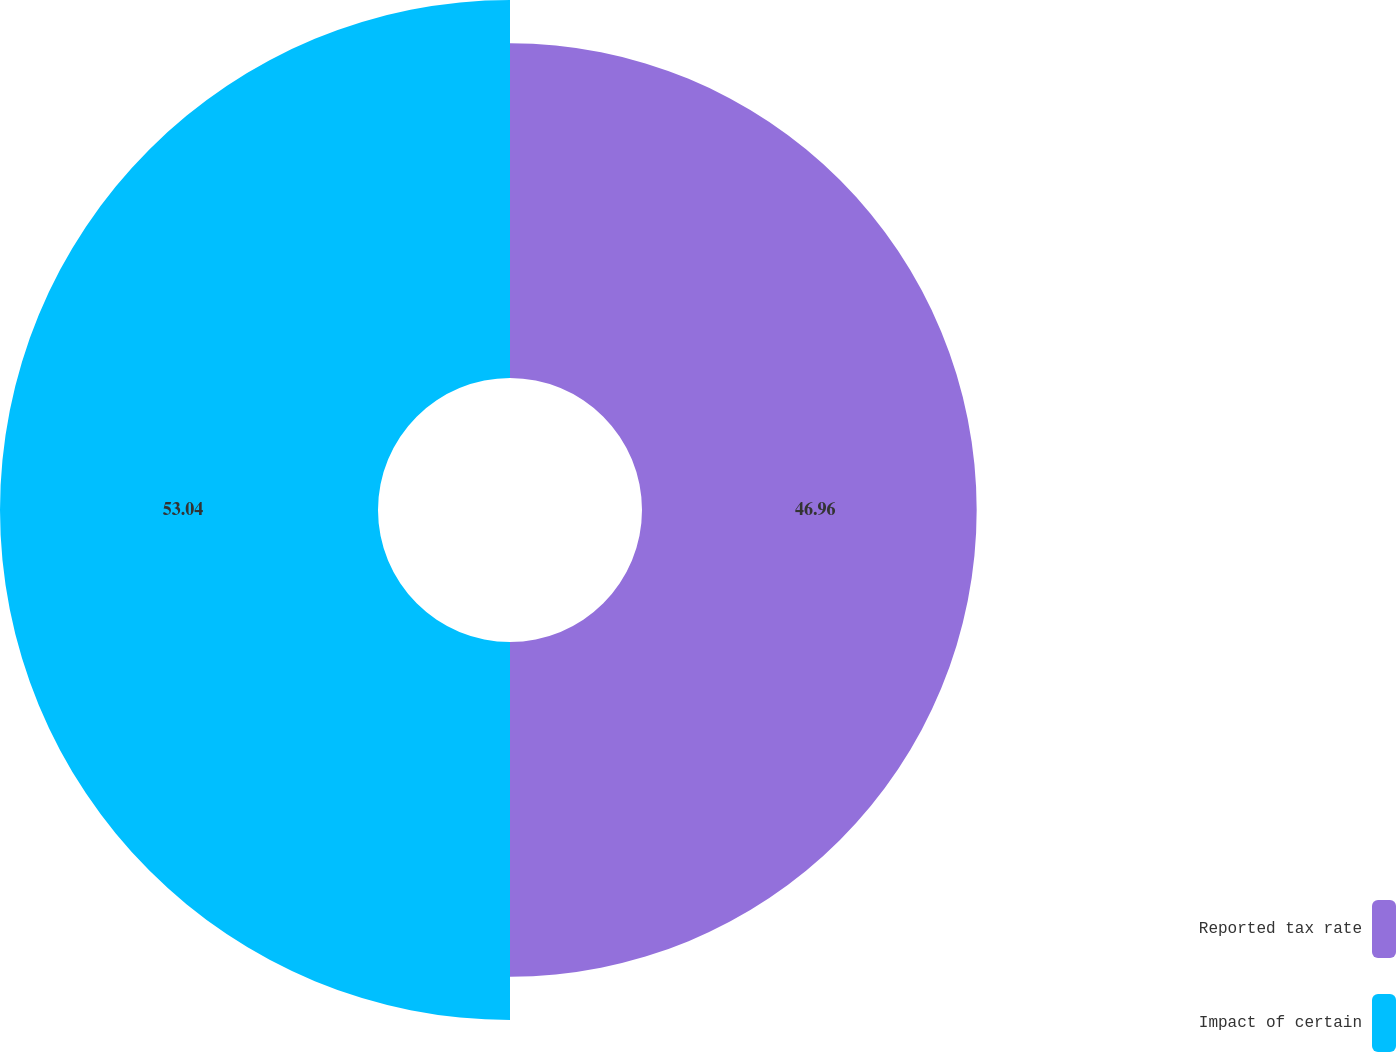Convert chart. <chart><loc_0><loc_0><loc_500><loc_500><pie_chart><fcel>Reported tax rate<fcel>Impact of certain<nl><fcel>46.96%<fcel>53.04%<nl></chart> 